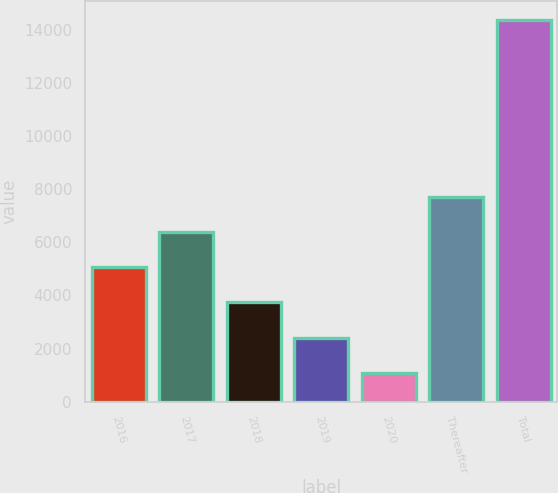<chart> <loc_0><loc_0><loc_500><loc_500><bar_chart><fcel>2016<fcel>2017<fcel>2018<fcel>2019<fcel>2020<fcel>Thereafter<fcel>Total<nl><fcel>5064.1<fcel>6393.8<fcel>3734.4<fcel>2404.7<fcel>1075<fcel>7723.5<fcel>14372<nl></chart> 